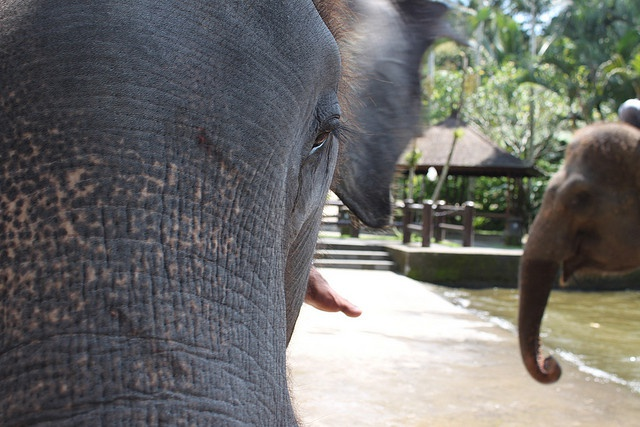Describe the objects in this image and their specific colors. I can see elephant in gray, black, and darkgray tones, elephant in gray, black, and maroon tones, and people in gray, maroon, brown, lightgray, and pink tones in this image. 